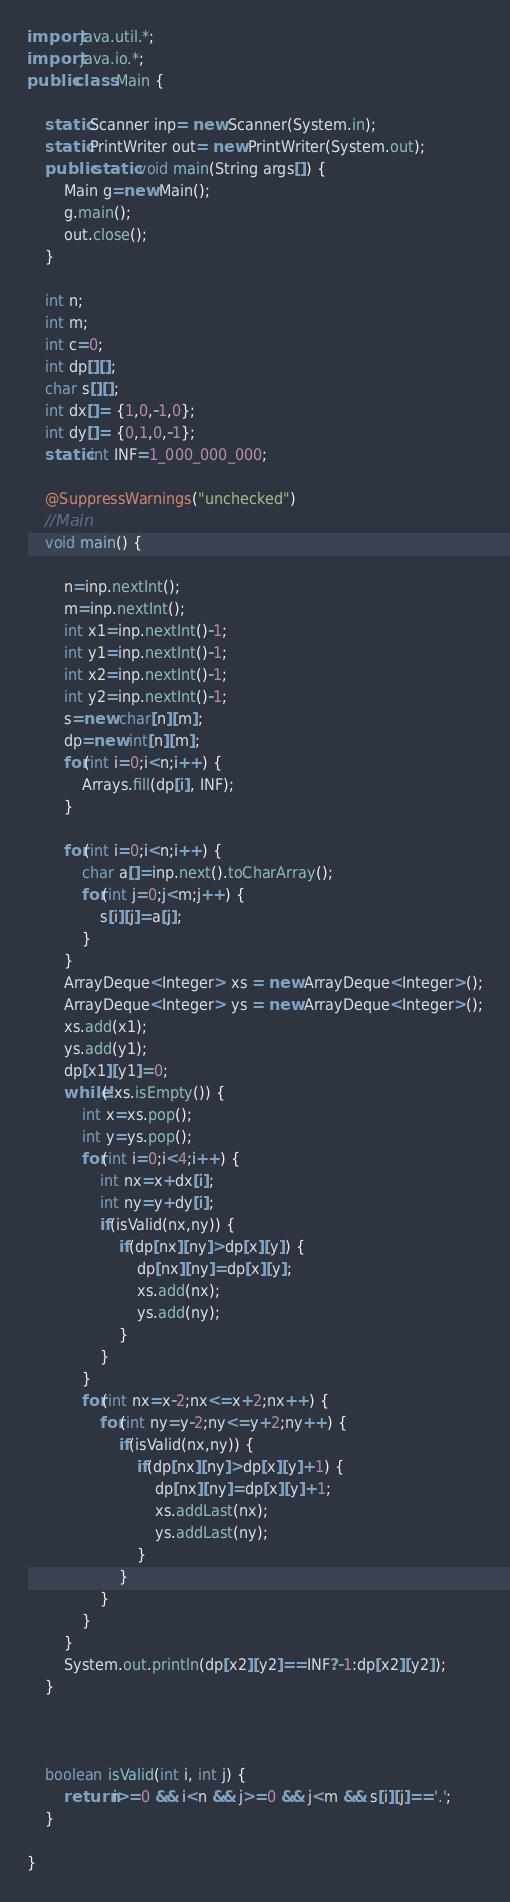<code> <loc_0><loc_0><loc_500><loc_500><_Java_>import java.util.*;
import java.io.*;
public class Main {

	static Scanner inp= new Scanner(System.in);
	static PrintWriter out= new PrintWriter(System.out);
	public static void main(String args[]) {		    	
	   	Main g=new Main();
	   	g.main();
	   	out.close();
	}

	int n;
	int m;
	int c=0;
	int dp[][];
	char s[][];
	int dx[]= {1,0,-1,0};
	int dy[]= {0,1,0,-1};
	static int INF=1_000_000_000;
	
	@SuppressWarnings("unchecked")
	//Main
	void main() {
		
		n=inp.nextInt();
		m=inp.nextInt();
		int x1=inp.nextInt()-1;
		int y1=inp.nextInt()-1;
		int x2=inp.nextInt()-1;
		int y2=inp.nextInt()-1;
		s=new char[n][m];
		dp=new int[n][m];
		for(int i=0;i<n;i++) {
			Arrays.fill(dp[i], INF);
		}
		
		for(int i=0;i<n;i++) {
			char a[]=inp.next().toCharArray();
			for(int j=0;j<m;j++) {
				s[i][j]=a[j];
			}
		}
		ArrayDeque<Integer> xs = new ArrayDeque<Integer>();
		ArrayDeque<Integer> ys = new ArrayDeque<Integer>();
		xs.add(x1);
		ys.add(y1);
		dp[x1][y1]=0;
		while(!xs.isEmpty()) {
			int x=xs.pop();
			int y=ys.pop();
			for(int i=0;i<4;i++) {
				int nx=x+dx[i];
				int ny=y+dy[i];
				if(isValid(nx,ny)) {
					if(dp[nx][ny]>dp[x][y]) {
						dp[nx][ny]=dp[x][y];
						xs.add(nx);
						ys.add(ny);
					}
				}
			}
			for(int nx=x-2;nx<=x+2;nx++) {
				for(int ny=y-2;ny<=y+2;ny++) {
					if(isValid(nx,ny)) {
						if(dp[nx][ny]>dp[x][y]+1) {
							dp[nx][ny]=dp[x][y]+1;
							xs.addLast(nx);
							ys.addLast(ny);
						}
					}
				}
			}
		}
		System.out.println(dp[x2][y2]==INF?-1:dp[x2][y2]);
	}
    
    
    
    boolean isValid(int i, int j) {
    	return i>=0 && i<n && j>=0 && j<m && s[i][j]=='.';
    }
		
}
</code> 